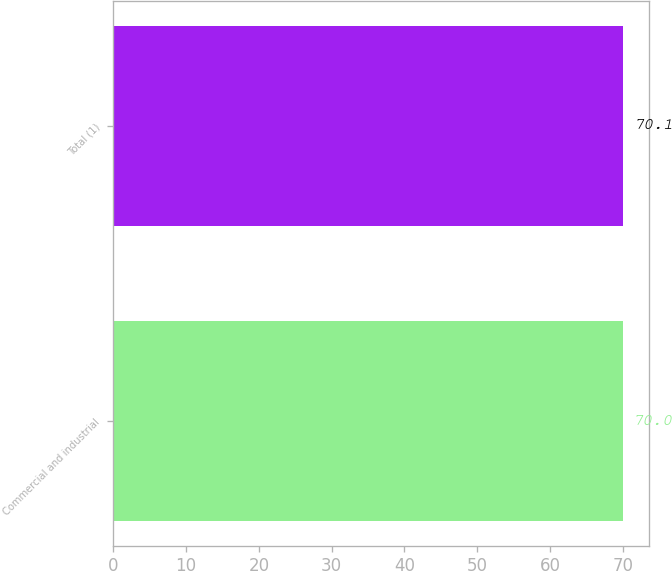Convert chart. <chart><loc_0><loc_0><loc_500><loc_500><bar_chart><fcel>Commercial and industrial<fcel>Total (1)<nl><fcel>70<fcel>70.1<nl></chart> 